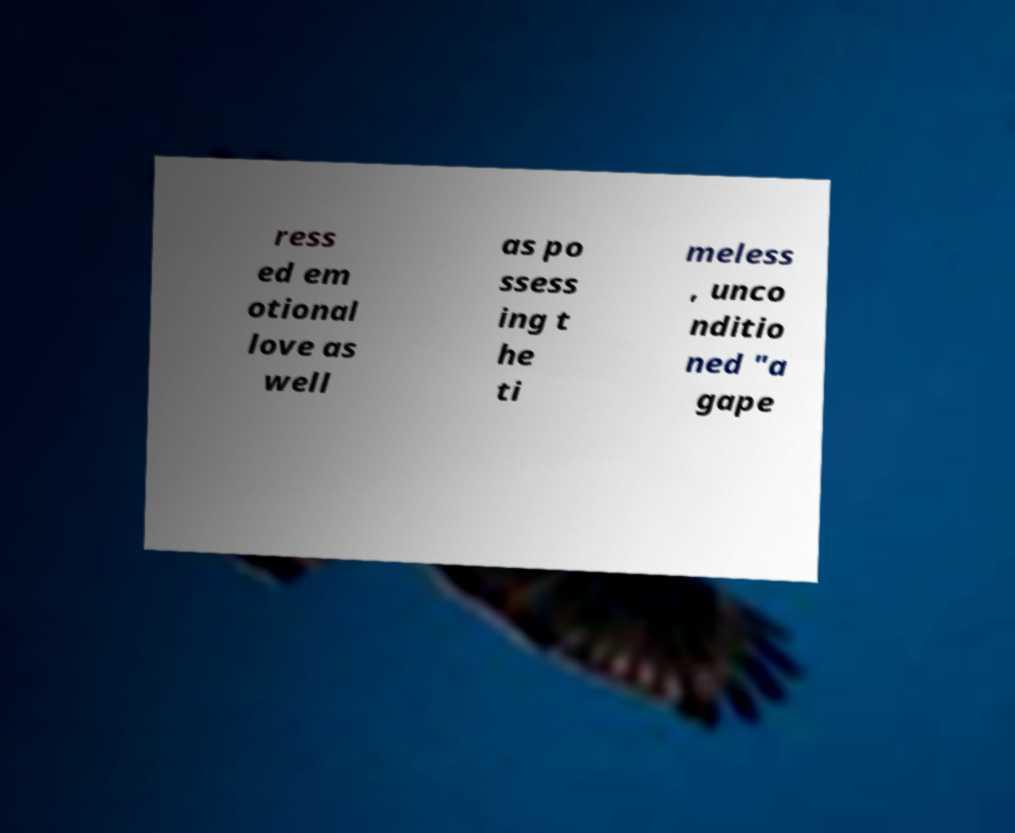For documentation purposes, I need the text within this image transcribed. Could you provide that? ress ed em otional love as well as po ssess ing t he ti meless , unco nditio ned "a gape 